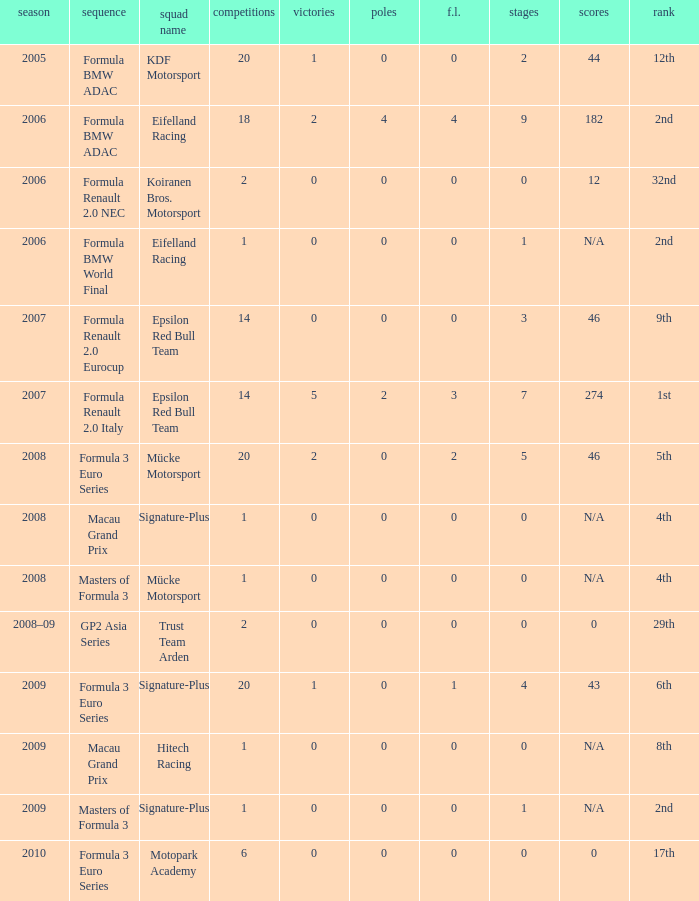What is the race in the 8th position? 1.0. 